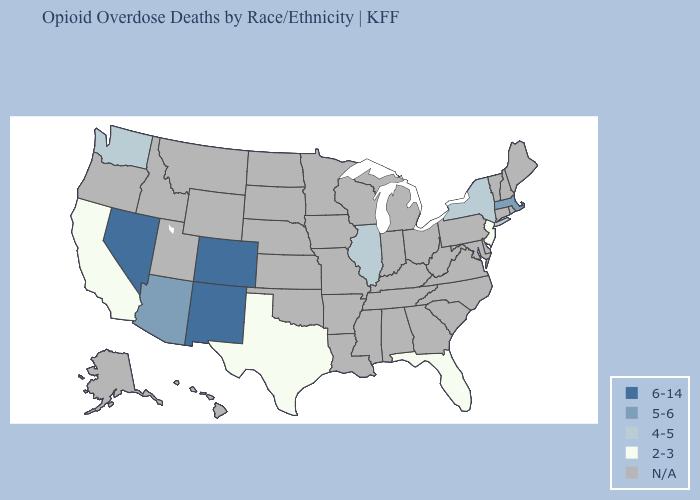Name the states that have a value in the range 5-6?
Answer briefly. Arizona, Massachusetts. Name the states that have a value in the range 2-3?
Be succinct. California, Florida, New Jersey, Texas. What is the value of Missouri?
Short answer required. N/A. Is the legend a continuous bar?
Keep it brief. No. Among the states that border Idaho , does Nevada have the highest value?
Be succinct. Yes. What is the value of Tennessee?
Keep it brief. N/A. Name the states that have a value in the range 4-5?
Write a very short answer. Illinois, New York, Washington. What is the value of Indiana?
Give a very brief answer. N/A. What is the lowest value in states that border Wyoming?
Answer briefly. 6-14. What is the lowest value in the MidWest?
Write a very short answer. 4-5. Does Florida have the lowest value in the USA?
Short answer required. Yes. How many symbols are there in the legend?
Short answer required. 5. What is the value of Missouri?
Write a very short answer. N/A. 